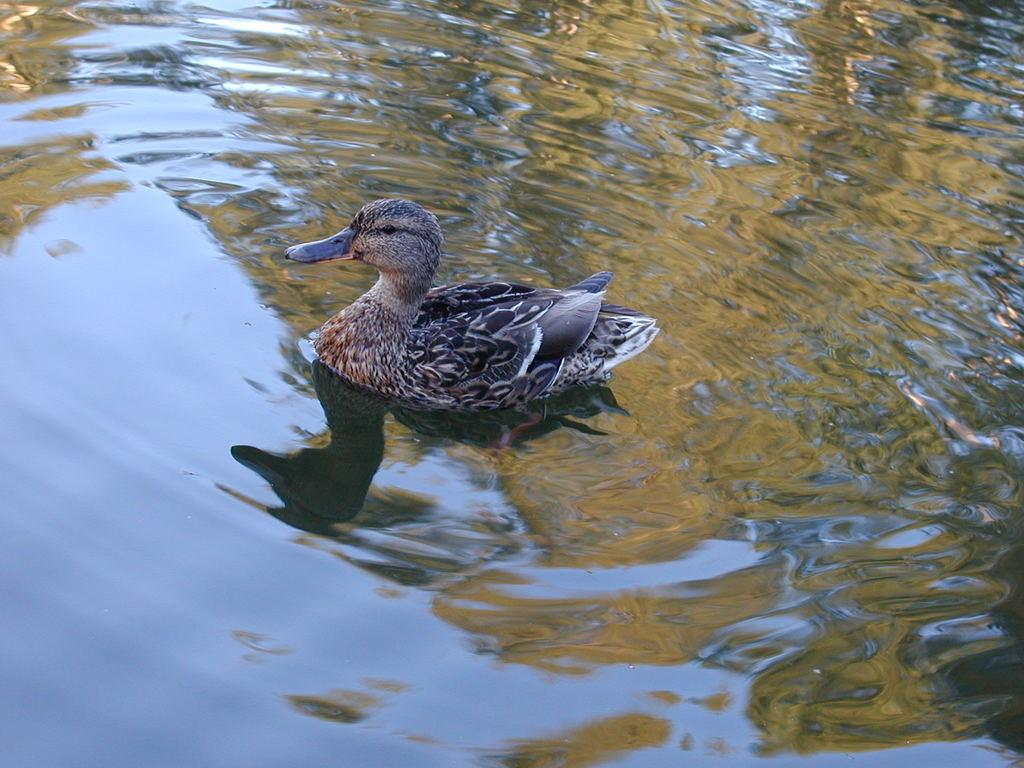What animal is present in the image? There is a duck in the image. Where is the duck located? The duck is floating in water. What type of straw is the duck using to build its nest in the image? There is no straw or nest visible in the image; the duck is simply floating in water. 